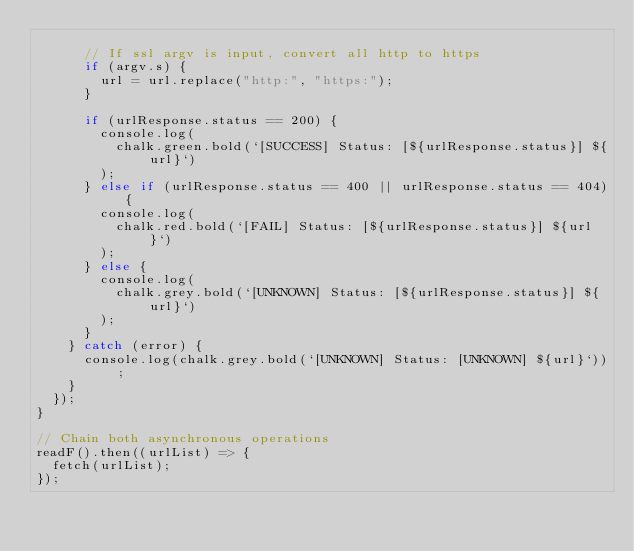Convert code to text. <code><loc_0><loc_0><loc_500><loc_500><_JavaScript_>
      // If ssl argv is input, convert all http to https
      if (argv.s) {
        url = url.replace("http:", "https:");
      }

      if (urlResponse.status == 200) {
        console.log(
          chalk.green.bold(`[SUCCESS] Status: [${urlResponse.status}] ${url}`)
        );
      } else if (urlResponse.status == 400 || urlResponse.status == 404) {
        console.log(
          chalk.red.bold(`[FAIL] Status: [${urlResponse.status}] ${url}`)
        );
      } else {
        console.log(
          chalk.grey.bold(`[UNKNOWN] Status: [${urlResponse.status}] ${url}`)
        );
      }
    } catch (error) {
      console.log(chalk.grey.bold(`[UNKNOWN] Status: [UNKNOWN] ${url}`));
    }
  });
}

// Chain both asynchronous operations
readF().then((urlList) => {
  fetch(urlList);
});
</code> 